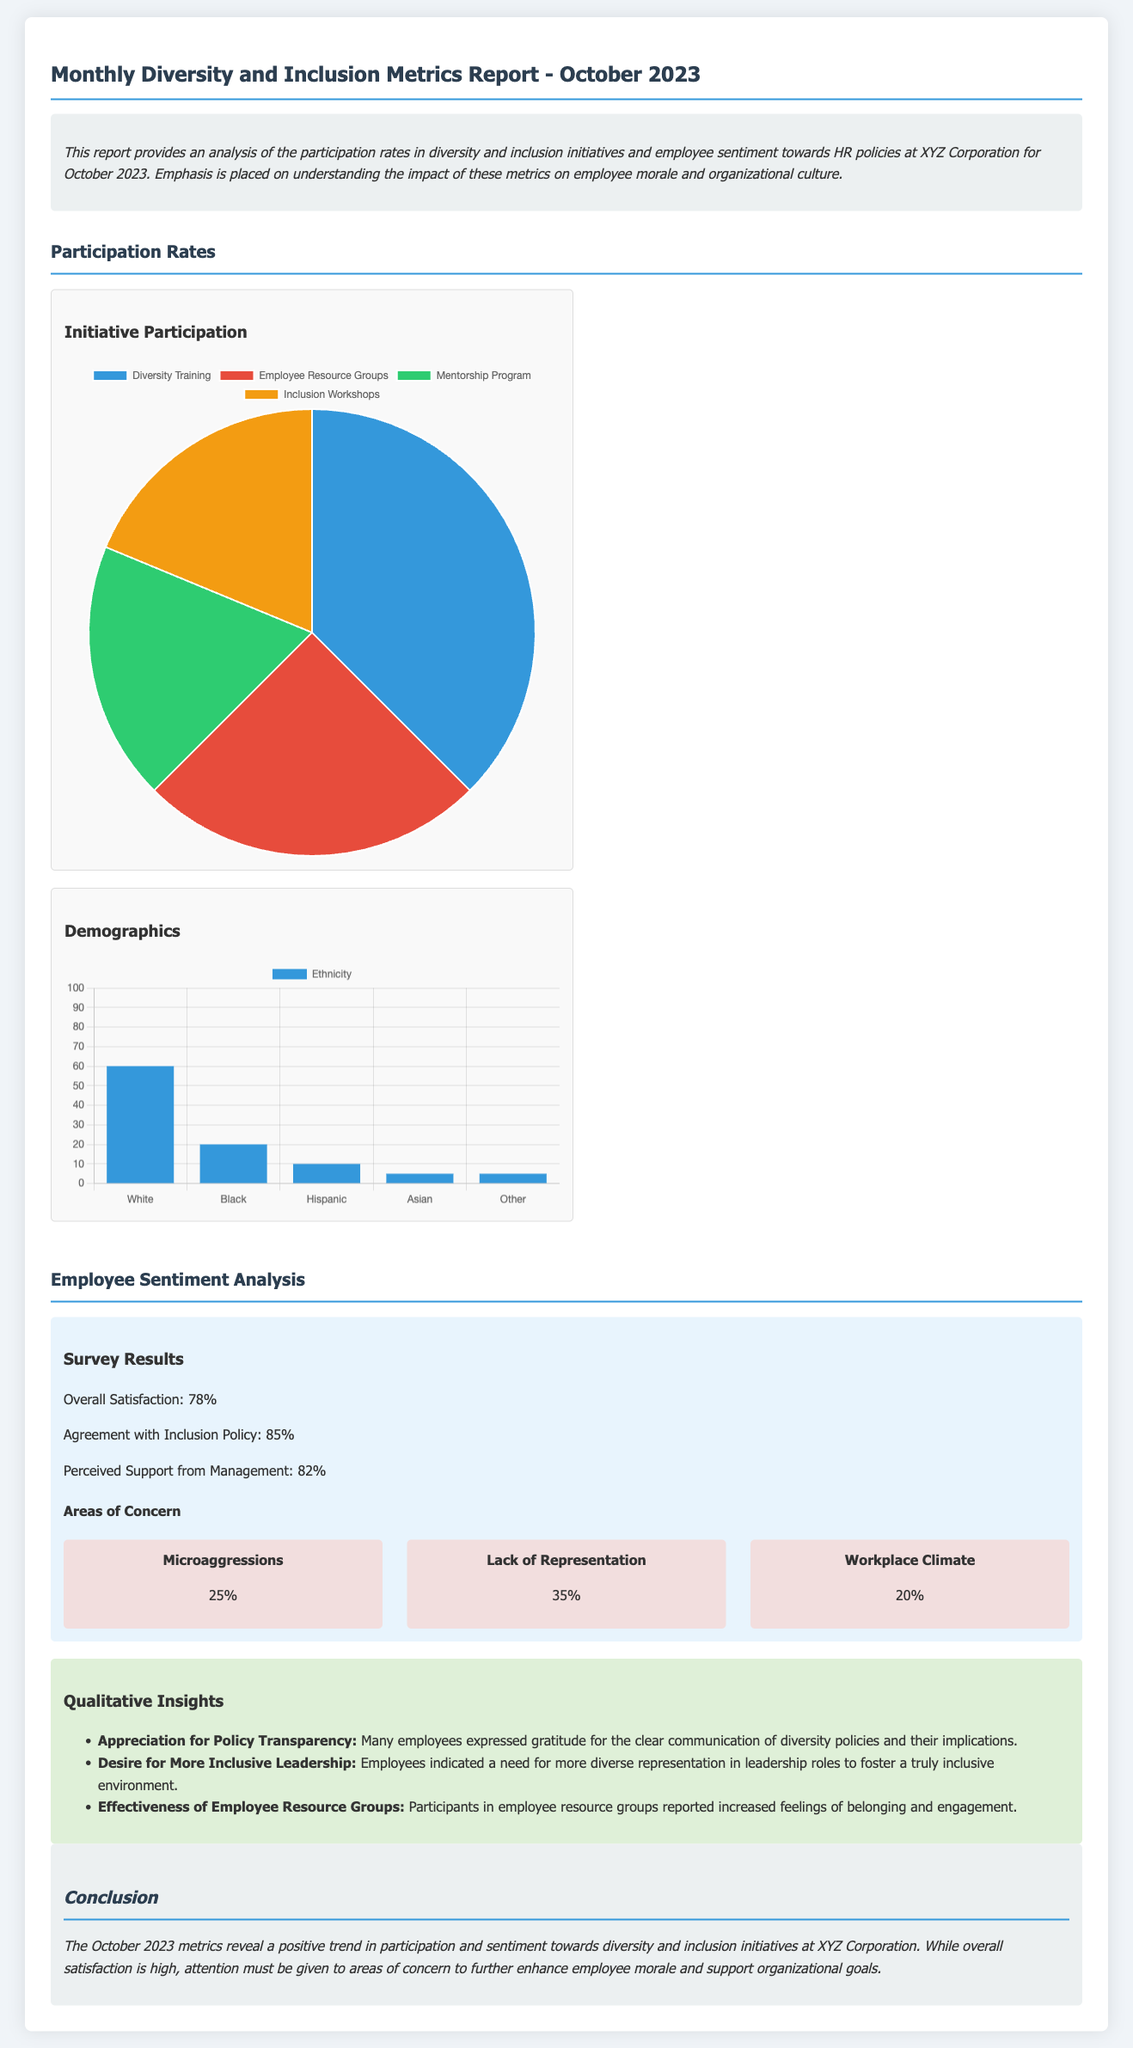What is the overall satisfaction percentage? The overall satisfaction is stated in the employee sentiment analysis section of the document, which shows an overall satisfaction of 78%.
Answer: 78% What percentage agreed with the inclusion policy? The document provides the percentage of employees who agree with the inclusion policy, which is 85%.
Answer: 85% What is the percentage of employees who reported experiencing microaggressions? The percentage of employees who reported experiencing microaggressions is specified in the areas of concern section, which shows 25%.
Answer: 25% Which diversity initiative had the highest participation rate? The initiative participation chart indicates that Diversity Training has the highest participation rate at 37.5%.
Answer: Diversity Training What is the total percentage of employees reporting a lack of representation? The document states that 35% of employees reported a lack of representation, which is a significant concern.
Answer: 35% What is the primary area of concern for employees as outlined in the document? The area with the highest concern from the employees is Lack of Representation at 35%.
Answer: Lack of Representation How many different demographic groups are represented in the demographics chart? The demographics chart lists five different demographic groups.
Answer: Five What insight did employees express regarding leadership? Employees expressed a desire for more inclusive leadership representation.
Answer: More inclusive leadership How does the document characterize the trend in employee sentiment? The conclusion section characterizes the trend in employee sentiment as positive.
Answer: Positive 